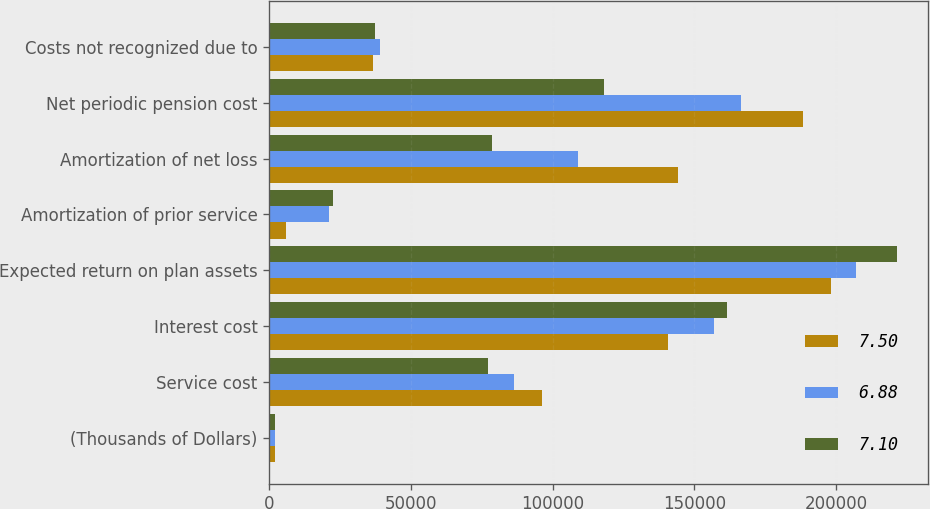Convert chart to OTSL. <chart><loc_0><loc_0><loc_500><loc_500><stacked_bar_chart><ecel><fcel>(Thousands of Dollars)<fcel>Service cost<fcel>Interest cost<fcel>Expected return on plan assets<fcel>Amortization of prior service<fcel>Amortization of net loss<fcel>Net periodic pension cost<fcel>Costs not recognized due to<nl><fcel>7.5<fcel>2013<fcel>96282<fcel>140690<fcel>198452<fcel>5871<fcel>144151<fcel>188542<fcel>36724<nl><fcel>6.88<fcel>2012<fcel>86364<fcel>157035<fcel>207095<fcel>21065<fcel>108982<fcel>166351<fcel>39217<nl><fcel>7.1<fcel>2011<fcel>77319<fcel>161412<fcel>221600<fcel>22533<fcel>78510<fcel>118174<fcel>37198<nl></chart> 